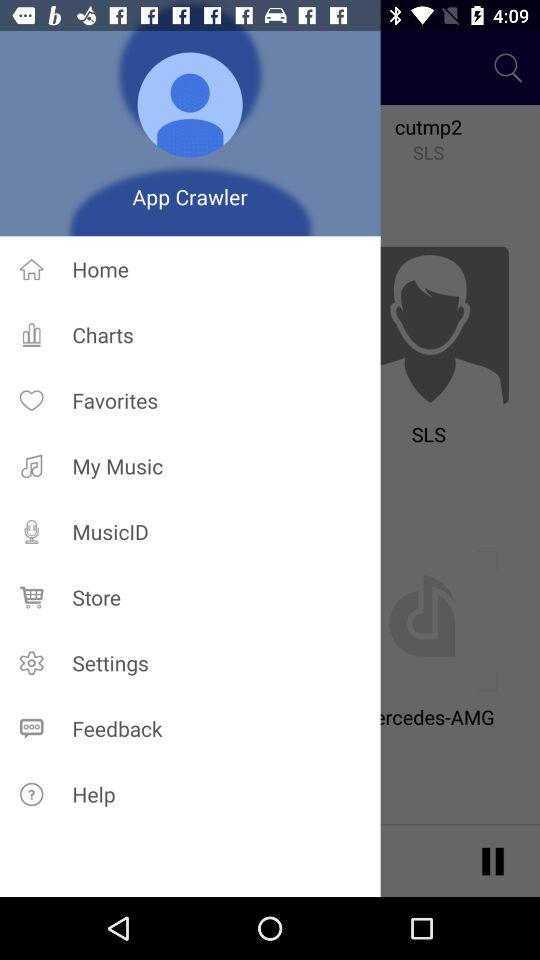What is the profile name? The profile name is App Crawler. 